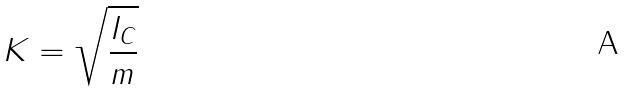<formula> <loc_0><loc_0><loc_500><loc_500>K = \sqrt { \frac { I _ { C } } { m } }</formula> 